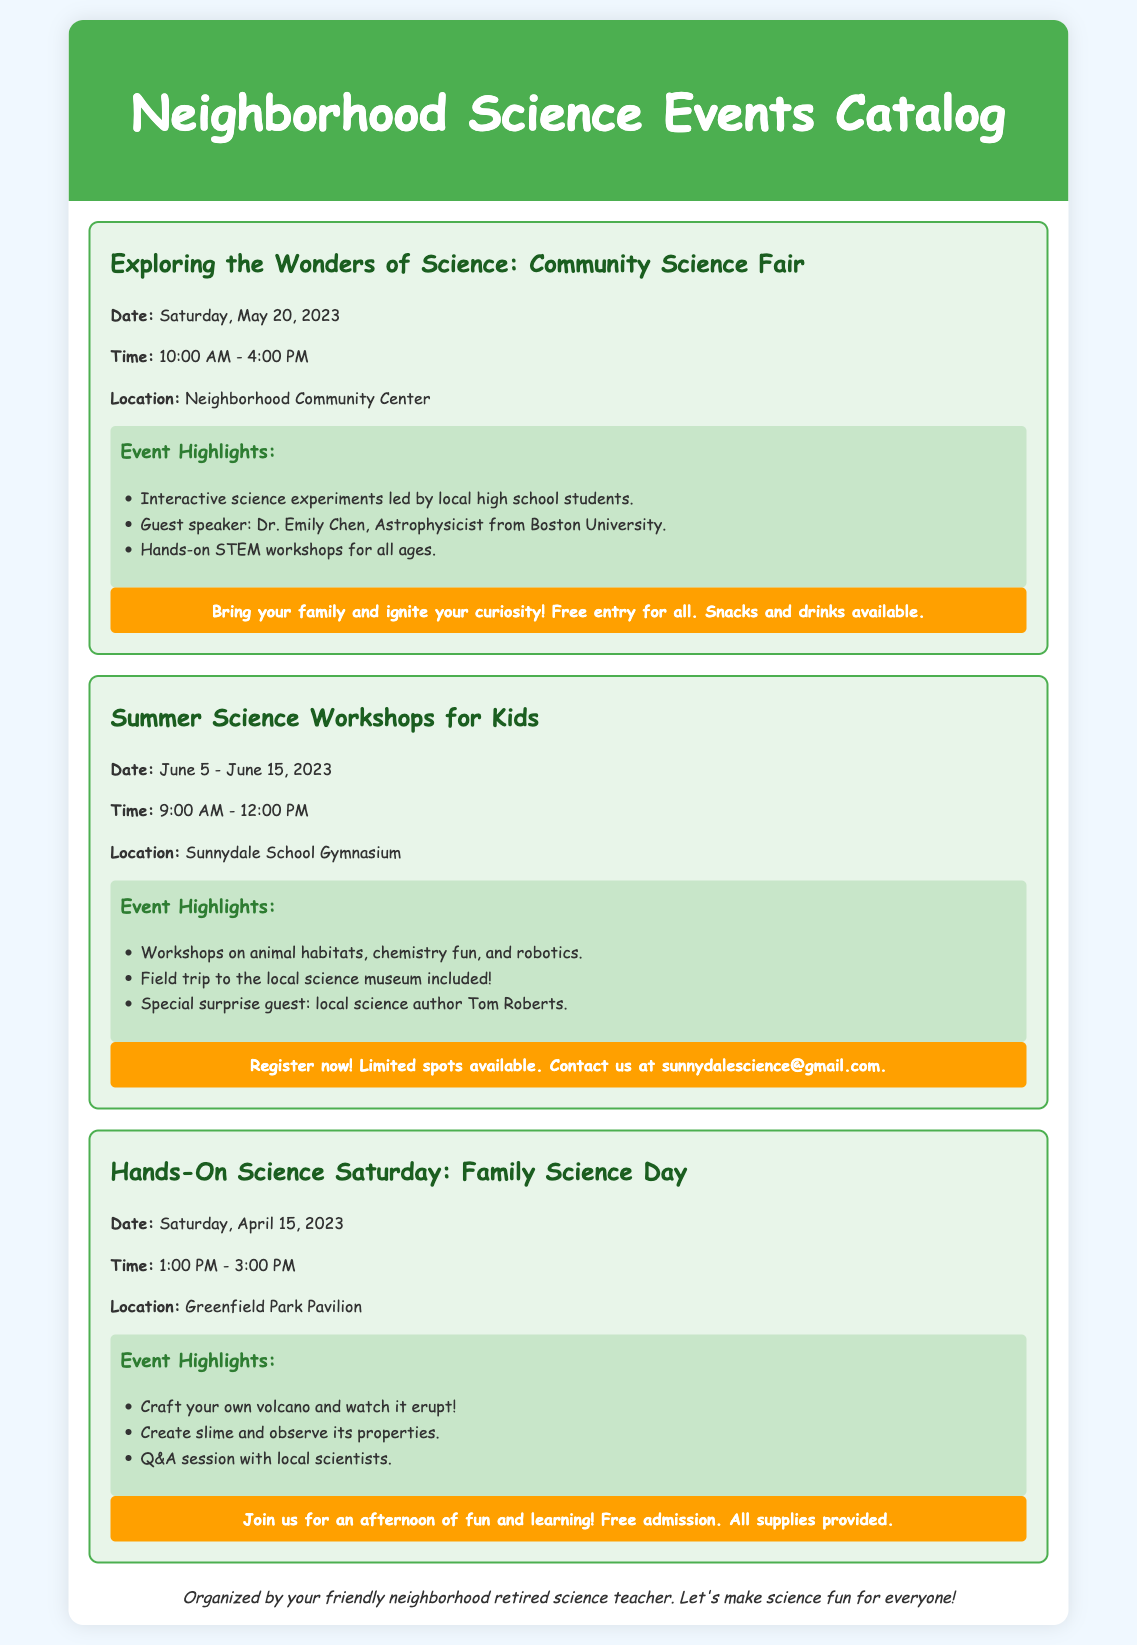What is the date of the Community Science Fair? The specific date for the Community Science Fair is stated in the document, which is Saturday, May 20, 2023.
Answer: Saturday, May 20, 2023 What time does the Summer Science Workshop start? The document specifies the starting time for the Summer Science Workshops, which is 9:00 AM.
Answer: 9:00 AM Who is the guest speaker at the Community Science Fair? The document mentions the guest speaker for the event, which is Dr. Emily Chen.
Answer: Dr. Emily Chen What type of activities can kids participate in during the Hands-On Science Saturday? The document describes the activities available at the Hands-On Science Saturday, which includes crafting a volcano and watching it erupt.
Answer: Craft your own volcano What is the email address to register for the Summer Science Workshops? The document provides the contact information for registration, specifically the email address sunnydalescience@gmail.com.
Answer: sunnydalescience@gmail.com How many days does the Summer Science Workshop last? The document details the duration of the Summer Science Workshops, which spans from June 5 to June 15, making it a total of 11 days.
Answer: 11 days What is offered at the Community Science Fair? The document lists a variety of activities at the Community Science Fair, highlighting interactive science experiments.
Answer: Interactive science experiments Is there an admission fee for the Hands-On Science Saturday? The document mentions the admission status for the Hands-On Science Saturday, indicating that it is free of charge.
Answer: Free admission What is the location for the Summer Science Workshops? The document states the specific location for the Summer Science Workshops, which is the Sunnydale School Gymnasium.
Answer: Sunnydale School Gymnasium 